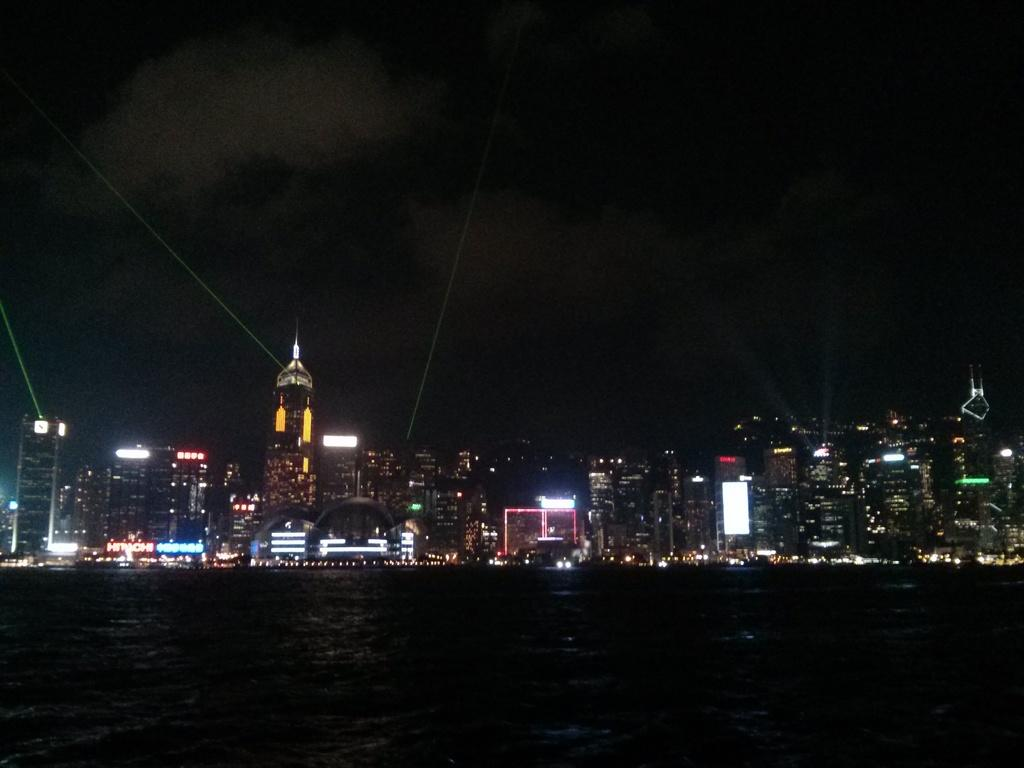What time of day is the image captured? The image is captured at night. What is the main feature of the landscape in the image? There is a water surface in the image. What type of structures can be seen in the image? There are many buildings and towers visible in the image. How does the image appear in terms of lighting and aesthetics? The view is beautiful with a lot of lights. What type of pipe is visible in the image? There is no pipe present in the image. How many nails can be seen holding the buildings together in the image? There are no nails visible in the image, as buildings are typically constructed using other materials and techniques. 